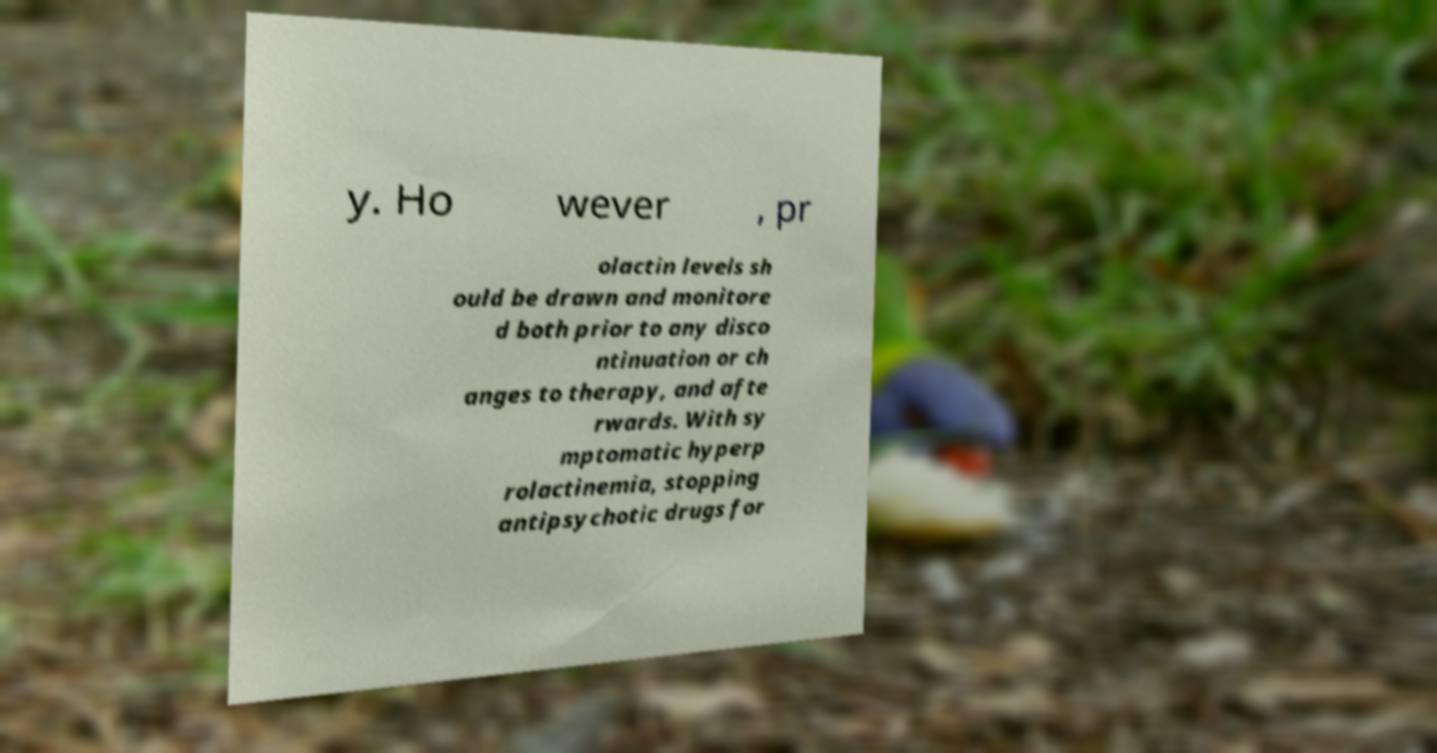There's text embedded in this image that I need extracted. Can you transcribe it verbatim? y. Ho wever , pr olactin levels sh ould be drawn and monitore d both prior to any disco ntinuation or ch anges to therapy, and afte rwards. With sy mptomatic hyperp rolactinemia, stopping antipsychotic drugs for 